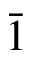Convert formula to latex. <formula><loc_0><loc_0><loc_500><loc_500>\ B a r { 1 }</formula> 